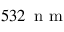<formula> <loc_0><loc_0><loc_500><loc_500>5 3 2 \, n m</formula> 